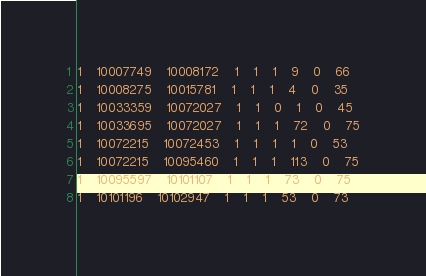Convert code to text. <code><loc_0><loc_0><loc_500><loc_500><_SQL_>1	10007749	10008172	1	1	1	9	0	66
1	10008275	10015781	1	1	1	4	0	35
1	10033359	10072027	1	1	0	1	0	45
1	10033695	10072027	1	1	1	72	0	75
1	10072215	10072453	1	1	1	1	0	53
1	10072215	10095460	1	1	1	113	0	75
1	10095597	10101107	1	1	1	73	0	75
1	10101196	10102947	1	1	1	53	0	73</code> 